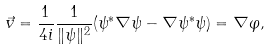Convert formula to latex. <formula><loc_0><loc_0><loc_500><loc_500>\vec { v } = \frac { 1 } { 4 i } \frac { 1 } { \| \psi \| ^ { 2 } } ( \psi ^ { * } \nabla \psi - \nabla \psi ^ { * } \psi ) = \nabla \varphi ,</formula> 